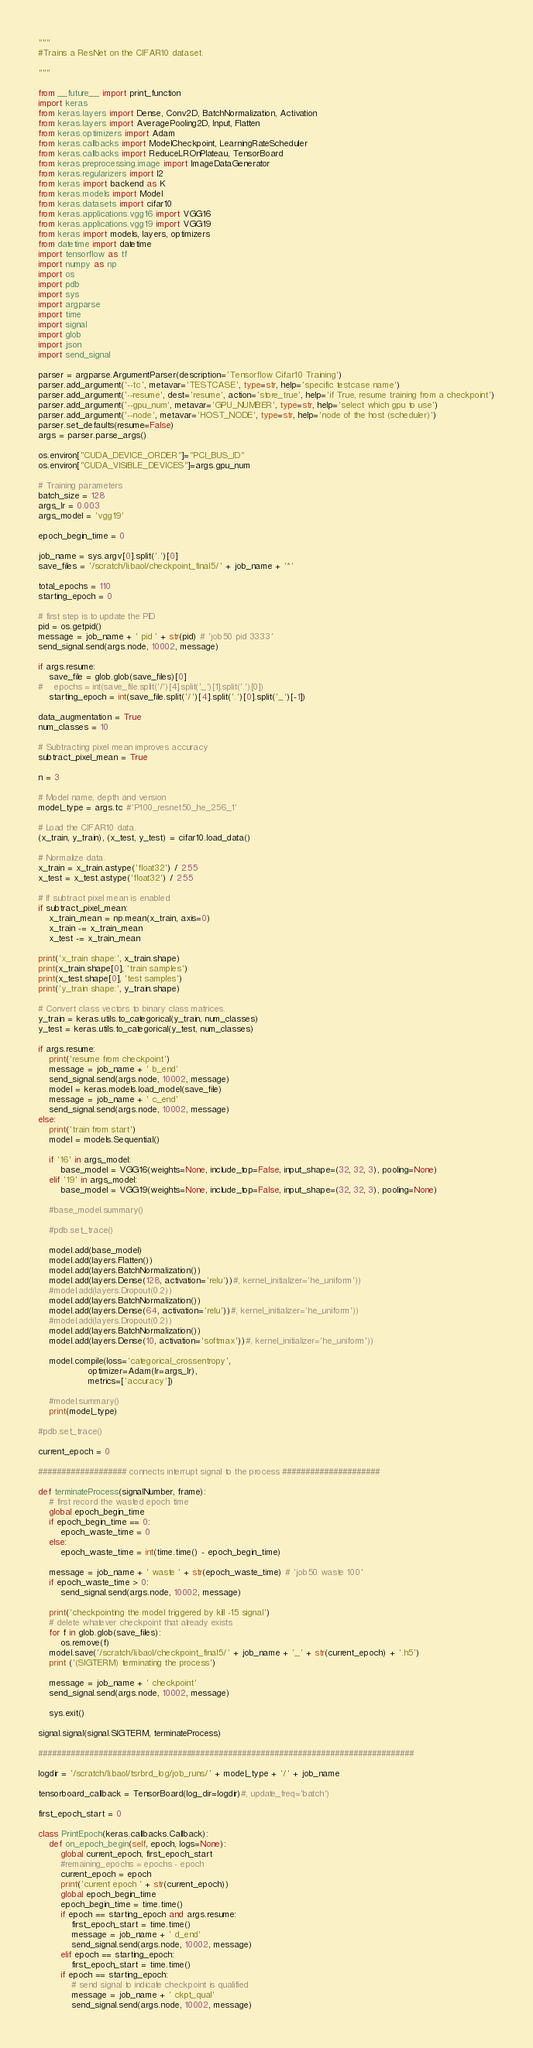<code> <loc_0><loc_0><loc_500><loc_500><_Python_>"""
#Trains a ResNet on the CIFAR10 dataset.

"""

from __future__ import print_function
import keras
from keras.layers import Dense, Conv2D, BatchNormalization, Activation
from keras.layers import AveragePooling2D, Input, Flatten
from keras.optimizers import Adam
from keras.callbacks import ModelCheckpoint, LearningRateScheduler
from keras.callbacks import ReduceLROnPlateau, TensorBoard
from keras.preprocessing.image import ImageDataGenerator
from keras.regularizers import l2
from keras import backend as K
from keras.models import Model
from keras.datasets import cifar10
from keras.applications.vgg16 import VGG16
from keras.applications.vgg19 import VGG19
from keras import models, layers, optimizers
from datetime import datetime
import tensorflow as tf
import numpy as np
import os
import pdb
import sys
import argparse
import time
import signal
import glob
import json
import send_signal

parser = argparse.ArgumentParser(description='Tensorflow Cifar10 Training')
parser.add_argument('--tc', metavar='TESTCASE', type=str, help='specific testcase name')
parser.add_argument('--resume', dest='resume', action='store_true', help='if True, resume training from a checkpoint')
parser.add_argument('--gpu_num', metavar='GPU_NUMBER', type=str, help='select which gpu to use')
parser.add_argument('--node', metavar='HOST_NODE', type=str, help='node of the host (scheduler)')
parser.set_defaults(resume=False)
args = parser.parse_args()

os.environ["CUDA_DEVICE_ORDER"]="PCI_BUS_ID"
os.environ["CUDA_VISIBLE_DEVICES"]=args.gpu_num

# Training parameters
batch_size = 128
args_lr = 0.003
args_model = 'vgg19'

epoch_begin_time = 0

job_name = sys.argv[0].split('.')[0]
save_files = '/scratch/li.baol/checkpoint_final5/' + job_name + '*'

total_epochs = 110 
starting_epoch = 0

# first step is to update the PID
pid = os.getpid()
message = job_name + ' pid ' + str(pid) # 'job50 pid 3333'
send_signal.send(args.node, 10002, message)

if args.resume:
    save_file = glob.glob(save_files)[0]
#    epochs = int(save_file.split('/')[4].split('_')[1].split('.')[0])
    starting_epoch = int(save_file.split('/')[4].split('.')[0].split('_')[-1])

data_augmentation = True
num_classes = 10

# Subtracting pixel mean improves accuracy
subtract_pixel_mean = True

n = 3

# Model name, depth and version
model_type = args.tc #'P100_resnet50_he_256_1'

# Load the CIFAR10 data.
(x_train, y_train), (x_test, y_test) = cifar10.load_data()

# Normalize data.
x_train = x_train.astype('float32') / 255
x_test = x_test.astype('float32') / 255

# If subtract pixel mean is enabled
if subtract_pixel_mean:
    x_train_mean = np.mean(x_train, axis=0)
    x_train -= x_train_mean
    x_test -= x_train_mean

print('x_train shape:', x_train.shape)
print(x_train.shape[0], 'train samples')
print(x_test.shape[0], 'test samples')
print('y_train shape:', y_train.shape)

# Convert class vectors to binary class matrices.
y_train = keras.utils.to_categorical(y_train, num_classes)
y_test = keras.utils.to_categorical(y_test, num_classes)

if args.resume:
    print('resume from checkpoint')
    message = job_name + ' b_end'
    send_signal.send(args.node, 10002, message)
    model = keras.models.load_model(save_file)
    message = job_name + ' c_end'
    send_signal.send(args.node, 10002, message)
else:
    print('train from start')
    model = models.Sequential()
    
    if '16' in args_model:
        base_model = VGG16(weights=None, include_top=False, input_shape=(32, 32, 3), pooling=None)
    elif '19' in args_model:
        base_model = VGG19(weights=None, include_top=False, input_shape=(32, 32, 3), pooling=None)
    
    #base_model.summary()
    
    #pdb.set_trace()
    
    model.add(base_model)
    model.add(layers.Flatten())
    model.add(layers.BatchNormalization())
    model.add(layers.Dense(128, activation='relu'))#, kernel_initializer='he_uniform'))
    #model.add(layers.Dropout(0.2))
    model.add(layers.BatchNormalization())
    model.add(layers.Dense(64, activation='relu'))#, kernel_initializer='he_uniform'))
    #model.add(layers.Dropout(0.2))
    model.add(layers.BatchNormalization())
    model.add(layers.Dense(10, activation='softmax'))#, kernel_initializer='he_uniform'))
    
    model.compile(loss='categorical_crossentropy',
                  optimizer=Adam(lr=args_lr),
                  metrics=['accuracy'])
    
    #model.summary()
    print(model_type)

#pdb.set_trace()

current_epoch = 0

################### connects interrupt signal to the process #####################

def terminateProcess(signalNumber, frame):
    # first record the wasted epoch time
    global epoch_begin_time
    if epoch_begin_time == 0:
        epoch_waste_time = 0
    else:
        epoch_waste_time = int(time.time() - epoch_begin_time)

    message = job_name + ' waste ' + str(epoch_waste_time) # 'job50 waste 100'
    if epoch_waste_time > 0:
        send_signal.send(args.node, 10002, message)

    print('checkpointing the model triggered by kill -15 signal')
    # delete whatever checkpoint that already exists
    for f in glob.glob(save_files):
        os.remove(f)
    model.save('/scratch/li.baol/checkpoint_final5/' + job_name + '_' + str(current_epoch) + '.h5')
    print ('(SIGTERM) terminating the process')

    message = job_name + ' checkpoint'
    send_signal.send(args.node, 10002, message)

    sys.exit()

signal.signal(signal.SIGTERM, terminateProcess)

#################################################################################

logdir = '/scratch/li.baol/tsrbrd_log/job_runs/' + model_type + '/' + job_name

tensorboard_callback = TensorBoard(log_dir=logdir)#, update_freq='batch')

first_epoch_start = 0

class PrintEpoch(keras.callbacks.Callback):
    def on_epoch_begin(self, epoch, logs=None):
        global current_epoch, first_epoch_start
        #remaining_epochs = epochs - epoch
        current_epoch = epoch
        print('current epoch ' + str(current_epoch))
        global epoch_begin_time
        epoch_begin_time = time.time()
        if epoch == starting_epoch and args.resume:
            first_epoch_start = time.time()
            message = job_name + ' d_end'
            send_signal.send(args.node, 10002, message)
        elif epoch == starting_epoch:
            first_epoch_start = time.time()           
        if epoch == starting_epoch:
            # send signal to indicate checkpoint is qualified
            message = job_name + ' ckpt_qual'
            send_signal.send(args.node, 10002, message)

</code> 